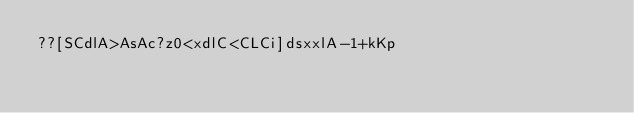<code> <loc_0><loc_0><loc_500><loc_500><_dc_>??[SCdlA>AsAc?z0<xdlC<CLCi]dsxxlA-1+kKp</code> 